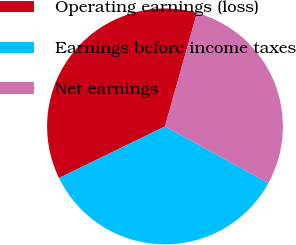Convert chart. <chart><loc_0><loc_0><loc_500><loc_500><pie_chart><fcel>Operating earnings (loss)<fcel>Earnings before income taxes<fcel>Net earnings<nl><fcel>36.58%<fcel>34.79%<fcel>28.63%<nl></chart> 